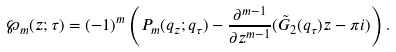Convert formula to latex. <formula><loc_0><loc_0><loc_500><loc_500>\wp _ { m } ( z ; \tau ) = ( - 1 ) ^ { m } \left ( P _ { m } ( q _ { z } ; q _ { \tau } ) - \frac { \partial ^ { m - 1 } } { \partial z ^ { m - 1 } } ( \tilde { G } _ { 2 } ( q _ { \tau } ) z - \pi i ) \right ) .</formula> 